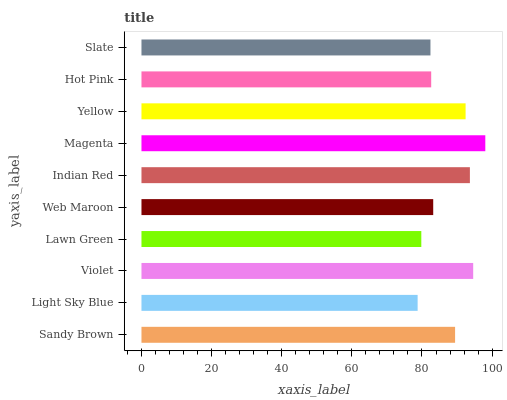Is Light Sky Blue the minimum?
Answer yes or no. Yes. Is Magenta the maximum?
Answer yes or no. Yes. Is Violet the minimum?
Answer yes or no. No. Is Violet the maximum?
Answer yes or no. No. Is Violet greater than Light Sky Blue?
Answer yes or no. Yes. Is Light Sky Blue less than Violet?
Answer yes or no. Yes. Is Light Sky Blue greater than Violet?
Answer yes or no. No. Is Violet less than Light Sky Blue?
Answer yes or no. No. Is Sandy Brown the high median?
Answer yes or no. Yes. Is Web Maroon the low median?
Answer yes or no. Yes. Is Indian Red the high median?
Answer yes or no. No. Is Yellow the low median?
Answer yes or no. No. 